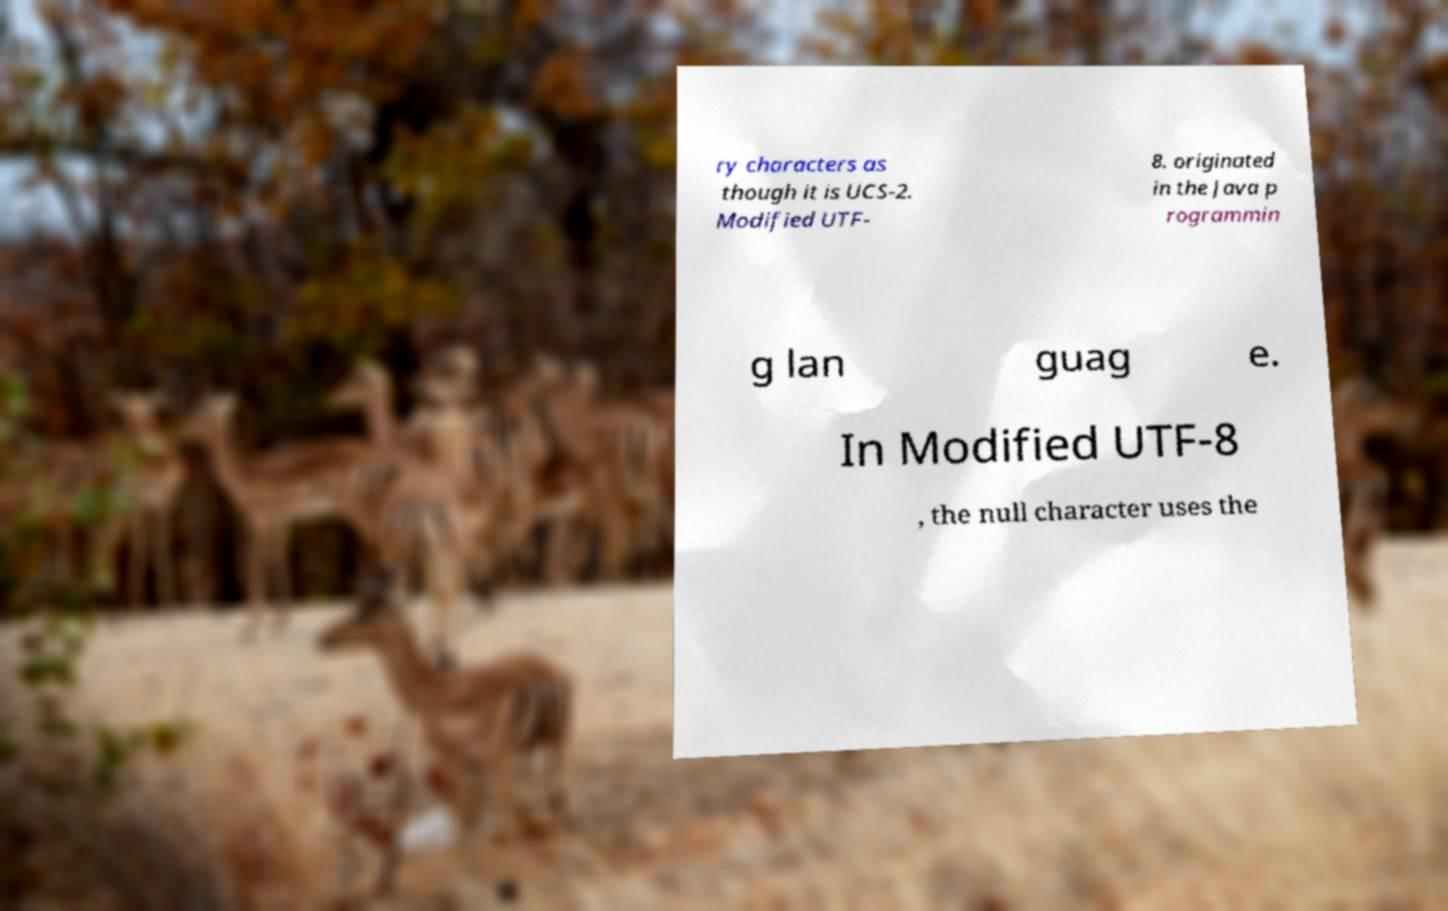Can you accurately transcribe the text from the provided image for me? ry characters as though it is UCS-2. Modified UTF- 8. originated in the Java p rogrammin g lan guag e. In Modified UTF-8 , the null character uses the 